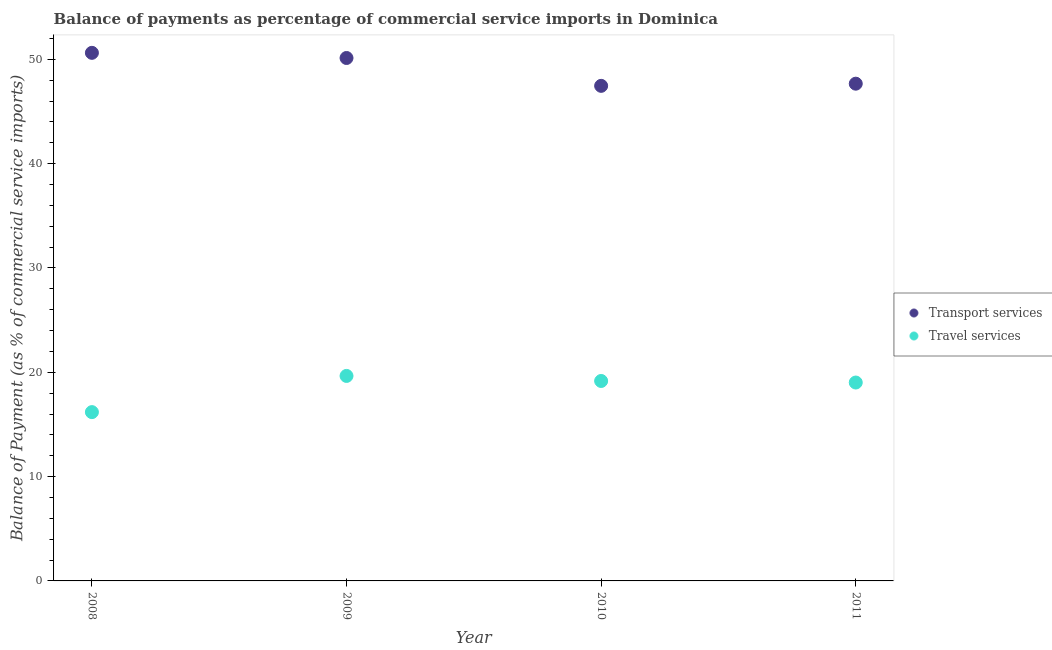How many different coloured dotlines are there?
Provide a short and direct response. 2. Is the number of dotlines equal to the number of legend labels?
Give a very brief answer. Yes. What is the balance of payments of travel services in 2009?
Your answer should be very brief. 19.65. Across all years, what is the maximum balance of payments of transport services?
Offer a terse response. 50.62. Across all years, what is the minimum balance of payments of travel services?
Offer a very short reply. 16.18. What is the total balance of payments of transport services in the graph?
Ensure brevity in your answer.  195.86. What is the difference between the balance of payments of transport services in 2008 and that in 2011?
Your response must be concise. 2.96. What is the difference between the balance of payments of transport services in 2010 and the balance of payments of travel services in 2009?
Keep it short and to the point. 27.8. What is the average balance of payments of transport services per year?
Your answer should be compact. 48.96. In the year 2009, what is the difference between the balance of payments of transport services and balance of payments of travel services?
Offer a very short reply. 30.47. What is the ratio of the balance of payments of travel services in 2008 to that in 2010?
Keep it short and to the point. 0.84. Is the balance of payments of transport services in 2008 less than that in 2009?
Keep it short and to the point. No. What is the difference between the highest and the second highest balance of payments of transport services?
Give a very brief answer. 0.49. What is the difference between the highest and the lowest balance of payments of transport services?
Your response must be concise. 3.16. Is the balance of payments of transport services strictly greater than the balance of payments of travel services over the years?
Your answer should be very brief. Yes. Is the balance of payments of transport services strictly less than the balance of payments of travel services over the years?
Ensure brevity in your answer.  No. Are the values on the major ticks of Y-axis written in scientific E-notation?
Ensure brevity in your answer.  No. Does the graph contain any zero values?
Provide a short and direct response. No. How many legend labels are there?
Provide a succinct answer. 2. What is the title of the graph?
Offer a very short reply. Balance of payments as percentage of commercial service imports in Dominica. Does "Personal remittances" appear as one of the legend labels in the graph?
Your response must be concise. No. What is the label or title of the Y-axis?
Offer a terse response. Balance of Payment (as % of commercial service imports). What is the Balance of Payment (as % of commercial service imports) in Transport services in 2008?
Your answer should be very brief. 50.62. What is the Balance of Payment (as % of commercial service imports) in Travel services in 2008?
Keep it short and to the point. 16.18. What is the Balance of Payment (as % of commercial service imports) of Transport services in 2009?
Provide a short and direct response. 50.12. What is the Balance of Payment (as % of commercial service imports) in Travel services in 2009?
Offer a very short reply. 19.65. What is the Balance of Payment (as % of commercial service imports) in Transport services in 2010?
Make the answer very short. 47.45. What is the Balance of Payment (as % of commercial service imports) in Travel services in 2010?
Make the answer very short. 19.17. What is the Balance of Payment (as % of commercial service imports) of Transport services in 2011?
Give a very brief answer. 47.66. What is the Balance of Payment (as % of commercial service imports) of Travel services in 2011?
Your answer should be compact. 19.02. Across all years, what is the maximum Balance of Payment (as % of commercial service imports) in Transport services?
Keep it short and to the point. 50.62. Across all years, what is the maximum Balance of Payment (as % of commercial service imports) of Travel services?
Offer a terse response. 19.65. Across all years, what is the minimum Balance of Payment (as % of commercial service imports) in Transport services?
Your response must be concise. 47.45. Across all years, what is the minimum Balance of Payment (as % of commercial service imports) of Travel services?
Offer a terse response. 16.18. What is the total Balance of Payment (as % of commercial service imports) in Transport services in the graph?
Ensure brevity in your answer.  195.86. What is the total Balance of Payment (as % of commercial service imports) in Travel services in the graph?
Make the answer very short. 74.01. What is the difference between the Balance of Payment (as % of commercial service imports) of Transport services in 2008 and that in 2009?
Keep it short and to the point. 0.49. What is the difference between the Balance of Payment (as % of commercial service imports) of Travel services in 2008 and that in 2009?
Offer a very short reply. -3.47. What is the difference between the Balance of Payment (as % of commercial service imports) of Transport services in 2008 and that in 2010?
Give a very brief answer. 3.16. What is the difference between the Balance of Payment (as % of commercial service imports) in Travel services in 2008 and that in 2010?
Offer a very short reply. -2.99. What is the difference between the Balance of Payment (as % of commercial service imports) in Transport services in 2008 and that in 2011?
Provide a short and direct response. 2.96. What is the difference between the Balance of Payment (as % of commercial service imports) of Travel services in 2008 and that in 2011?
Your answer should be very brief. -2.84. What is the difference between the Balance of Payment (as % of commercial service imports) of Transport services in 2009 and that in 2010?
Offer a very short reply. 2.67. What is the difference between the Balance of Payment (as % of commercial service imports) of Travel services in 2009 and that in 2010?
Your answer should be very brief. 0.48. What is the difference between the Balance of Payment (as % of commercial service imports) of Transport services in 2009 and that in 2011?
Keep it short and to the point. 2.46. What is the difference between the Balance of Payment (as % of commercial service imports) in Travel services in 2009 and that in 2011?
Provide a succinct answer. 0.63. What is the difference between the Balance of Payment (as % of commercial service imports) of Transport services in 2010 and that in 2011?
Your answer should be very brief. -0.21. What is the difference between the Balance of Payment (as % of commercial service imports) in Travel services in 2010 and that in 2011?
Give a very brief answer. 0.15. What is the difference between the Balance of Payment (as % of commercial service imports) in Transport services in 2008 and the Balance of Payment (as % of commercial service imports) in Travel services in 2009?
Ensure brevity in your answer.  30.97. What is the difference between the Balance of Payment (as % of commercial service imports) in Transport services in 2008 and the Balance of Payment (as % of commercial service imports) in Travel services in 2010?
Ensure brevity in your answer.  31.45. What is the difference between the Balance of Payment (as % of commercial service imports) in Transport services in 2008 and the Balance of Payment (as % of commercial service imports) in Travel services in 2011?
Provide a short and direct response. 31.6. What is the difference between the Balance of Payment (as % of commercial service imports) of Transport services in 2009 and the Balance of Payment (as % of commercial service imports) of Travel services in 2010?
Your answer should be very brief. 30.96. What is the difference between the Balance of Payment (as % of commercial service imports) of Transport services in 2009 and the Balance of Payment (as % of commercial service imports) of Travel services in 2011?
Your response must be concise. 31.11. What is the difference between the Balance of Payment (as % of commercial service imports) in Transport services in 2010 and the Balance of Payment (as % of commercial service imports) in Travel services in 2011?
Offer a terse response. 28.44. What is the average Balance of Payment (as % of commercial service imports) of Transport services per year?
Your answer should be very brief. 48.96. What is the average Balance of Payment (as % of commercial service imports) of Travel services per year?
Provide a short and direct response. 18.5. In the year 2008, what is the difference between the Balance of Payment (as % of commercial service imports) in Transport services and Balance of Payment (as % of commercial service imports) in Travel services?
Make the answer very short. 34.44. In the year 2009, what is the difference between the Balance of Payment (as % of commercial service imports) of Transport services and Balance of Payment (as % of commercial service imports) of Travel services?
Ensure brevity in your answer.  30.47. In the year 2010, what is the difference between the Balance of Payment (as % of commercial service imports) of Transport services and Balance of Payment (as % of commercial service imports) of Travel services?
Keep it short and to the point. 28.29. In the year 2011, what is the difference between the Balance of Payment (as % of commercial service imports) in Transport services and Balance of Payment (as % of commercial service imports) in Travel services?
Your answer should be very brief. 28.65. What is the ratio of the Balance of Payment (as % of commercial service imports) in Transport services in 2008 to that in 2009?
Ensure brevity in your answer.  1.01. What is the ratio of the Balance of Payment (as % of commercial service imports) of Travel services in 2008 to that in 2009?
Your response must be concise. 0.82. What is the ratio of the Balance of Payment (as % of commercial service imports) of Transport services in 2008 to that in 2010?
Your response must be concise. 1.07. What is the ratio of the Balance of Payment (as % of commercial service imports) of Travel services in 2008 to that in 2010?
Your answer should be very brief. 0.84. What is the ratio of the Balance of Payment (as % of commercial service imports) in Transport services in 2008 to that in 2011?
Offer a terse response. 1.06. What is the ratio of the Balance of Payment (as % of commercial service imports) of Travel services in 2008 to that in 2011?
Make the answer very short. 0.85. What is the ratio of the Balance of Payment (as % of commercial service imports) of Transport services in 2009 to that in 2010?
Your answer should be compact. 1.06. What is the ratio of the Balance of Payment (as % of commercial service imports) in Travel services in 2009 to that in 2010?
Make the answer very short. 1.03. What is the ratio of the Balance of Payment (as % of commercial service imports) of Transport services in 2009 to that in 2011?
Offer a terse response. 1.05. What is the ratio of the Balance of Payment (as % of commercial service imports) of Transport services in 2010 to that in 2011?
Provide a short and direct response. 1. What is the difference between the highest and the second highest Balance of Payment (as % of commercial service imports) in Transport services?
Offer a terse response. 0.49. What is the difference between the highest and the second highest Balance of Payment (as % of commercial service imports) in Travel services?
Your response must be concise. 0.48. What is the difference between the highest and the lowest Balance of Payment (as % of commercial service imports) in Transport services?
Ensure brevity in your answer.  3.16. What is the difference between the highest and the lowest Balance of Payment (as % of commercial service imports) in Travel services?
Your answer should be compact. 3.47. 